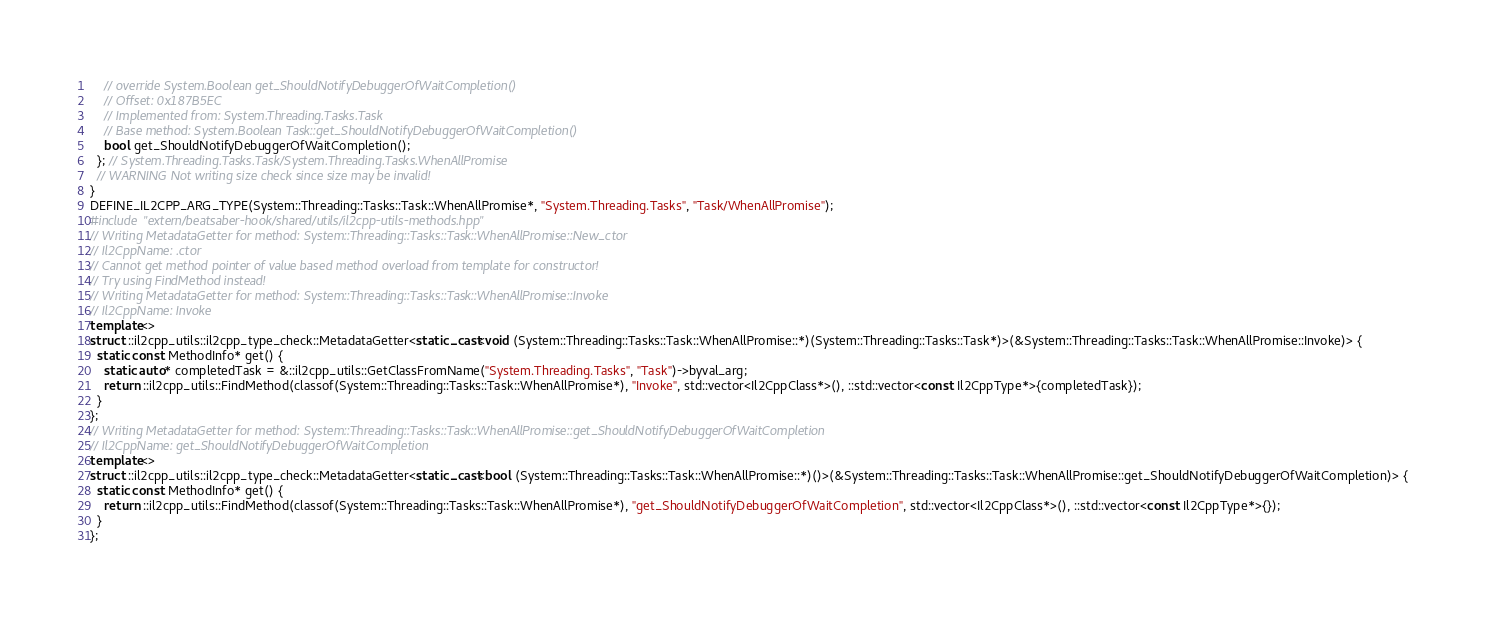Convert code to text. <code><loc_0><loc_0><loc_500><loc_500><_C++_>    // override System.Boolean get_ShouldNotifyDebuggerOfWaitCompletion()
    // Offset: 0x187B5EC
    // Implemented from: System.Threading.Tasks.Task
    // Base method: System.Boolean Task::get_ShouldNotifyDebuggerOfWaitCompletion()
    bool get_ShouldNotifyDebuggerOfWaitCompletion();
  }; // System.Threading.Tasks.Task/System.Threading.Tasks.WhenAllPromise
  // WARNING Not writing size check since size may be invalid!
}
DEFINE_IL2CPP_ARG_TYPE(System::Threading::Tasks::Task::WhenAllPromise*, "System.Threading.Tasks", "Task/WhenAllPromise");
#include "extern/beatsaber-hook/shared/utils/il2cpp-utils-methods.hpp"
// Writing MetadataGetter for method: System::Threading::Tasks::Task::WhenAllPromise::New_ctor
// Il2CppName: .ctor
// Cannot get method pointer of value based method overload from template for constructor!
// Try using FindMethod instead!
// Writing MetadataGetter for method: System::Threading::Tasks::Task::WhenAllPromise::Invoke
// Il2CppName: Invoke
template<>
struct ::il2cpp_utils::il2cpp_type_check::MetadataGetter<static_cast<void (System::Threading::Tasks::Task::WhenAllPromise::*)(System::Threading::Tasks::Task*)>(&System::Threading::Tasks::Task::WhenAllPromise::Invoke)> {
  static const MethodInfo* get() {
    static auto* completedTask = &::il2cpp_utils::GetClassFromName("System.Threading.Tasks", "Task")->byval_arg;
    return ::il2cpp_utils::FindMethod(classof(System::Threading::Tasks::Task::WhenAllPromise*), "Invoke", std::vector<Il2CppClass*>(), ::std::vector<const Il2CppType*>{completedTask});
  }
};
// Writing MetadataGetter for method: System::Threading::Tasks::Task::WhenAllPromise::get_ShouldNotifyDebuggerOfWaitCompletion
// Il2CppName: get_ShouldNotifyDebuggerOfWaitCompletion
template<>
struct ::il2cpp_utils::il2cpp_type_check::MetadataGetter<static_cast<bool (System::Threading::Tasks::Task::WhenAllPromise::*)()>(&System::Threading::Tasks::Task::WhenAllPromise::get_ShouldNotifyDebuggerOfWaitCompletion)> {
  static const MethodInfo* get() {
    return ::il2cpp_utils::FindMethod(classof(System::Threading::Tasks::Task::WhenAllPromise*), "get_ShouldNotifyDebuggerOfWaitCompletion", std::vector<Il2CppClass*>(), ::std::vector<const Il2CppType*>{});
  }
};
</code> 